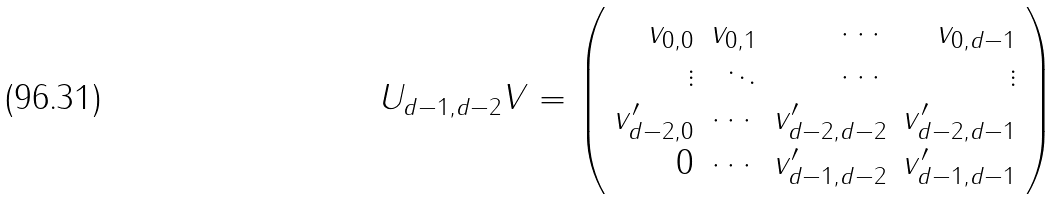<formula> <loc_0><loc_0><loc_500><loc_500>U _ { d - 1 , d - 2 } V = \left ( \begin{array} { r r r r } v _ { 0 , 0 } & v _ { 0 , 1 } & \cdots & v _ { 0 , d - 1 } \\ \vdots & \ddots & \cdots & \vdots \\ v ^ { \prime } _ { d - 2 , 0 } & \cdots & v ^ { \prime } _ { d - 2 , d - 2 } & v ^ { \prime } _ { d - 2 , d - 1 } \\ 0 & \cdots & v ^ { \prime } _ { d - 1 , d - 2 } & v ^ { \prime } _ { d - 1 , d - 1 } \\ \end{array} \right )</formula> 